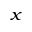Convert formula to latex. <formula><loc_0><loc_0><loc_500><loc_500>_ { x }</formula> 